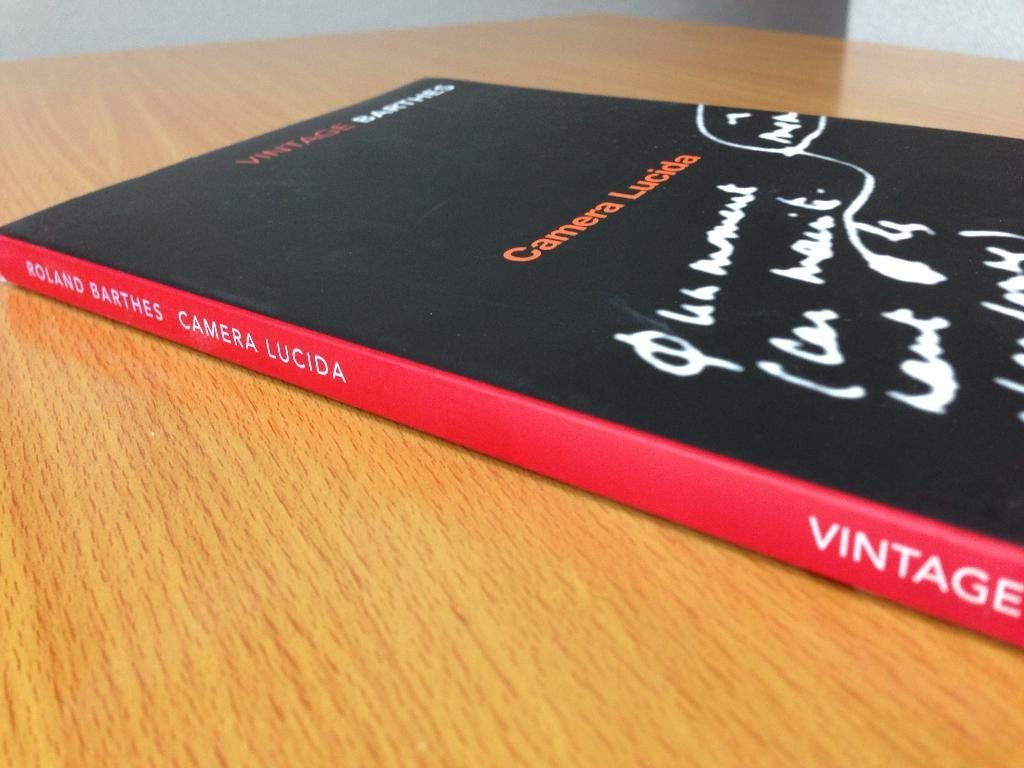Provide a one-sentence caption for the provided image. The book Camera Lucida by Roland Barthes on a wooden table. 